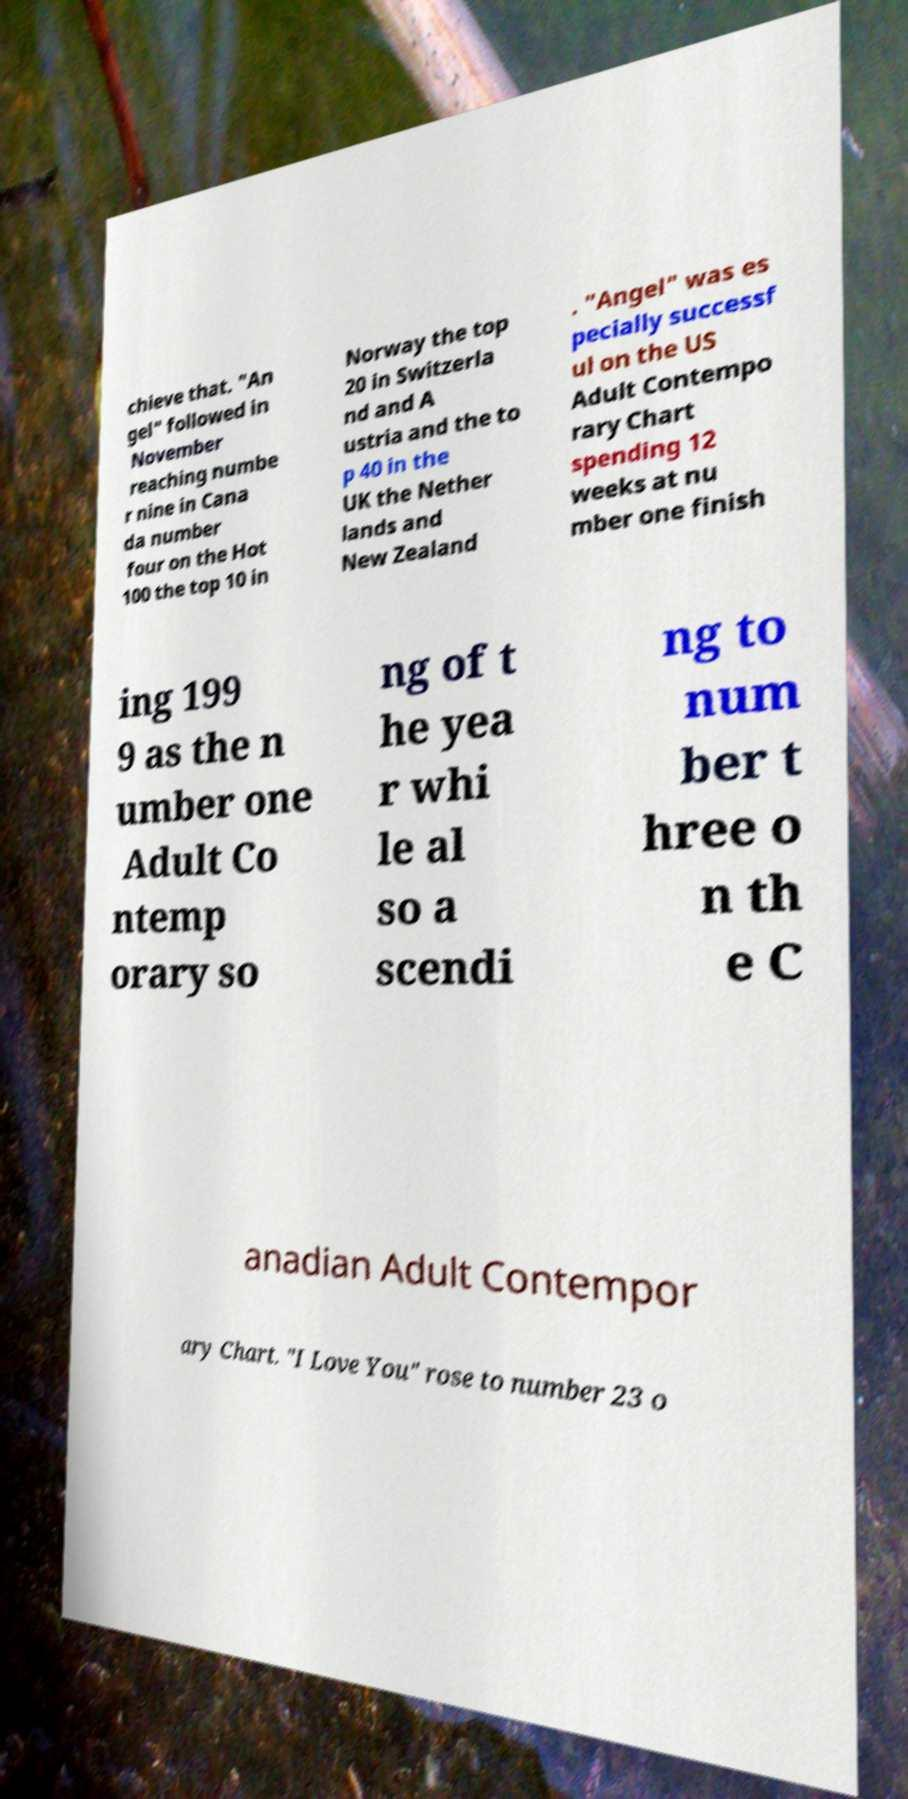What messages or text are displayed in this image? I need them in a readable, typed format. chieve that. "An gel" followed in November reaching numbe r nine in Cana da number four on the Hot 100 the top 10 in Norway the top 20 in Switzerla nd and A ustria and the to p 40 in the UK the Nether lands and New Zealand . "Angel" was es pecially successf ul on the US Adult Contempo rary Chart spending 12 weeks at nu mber one finish ing 199 9 as the n umber one Adult Co ntemp orary so ng of t he yea r whi le al so a scendi ng to num ber t hree o n th e C anadian Adult Contempor ary Chart. "I Love You" rose to number 23 o 